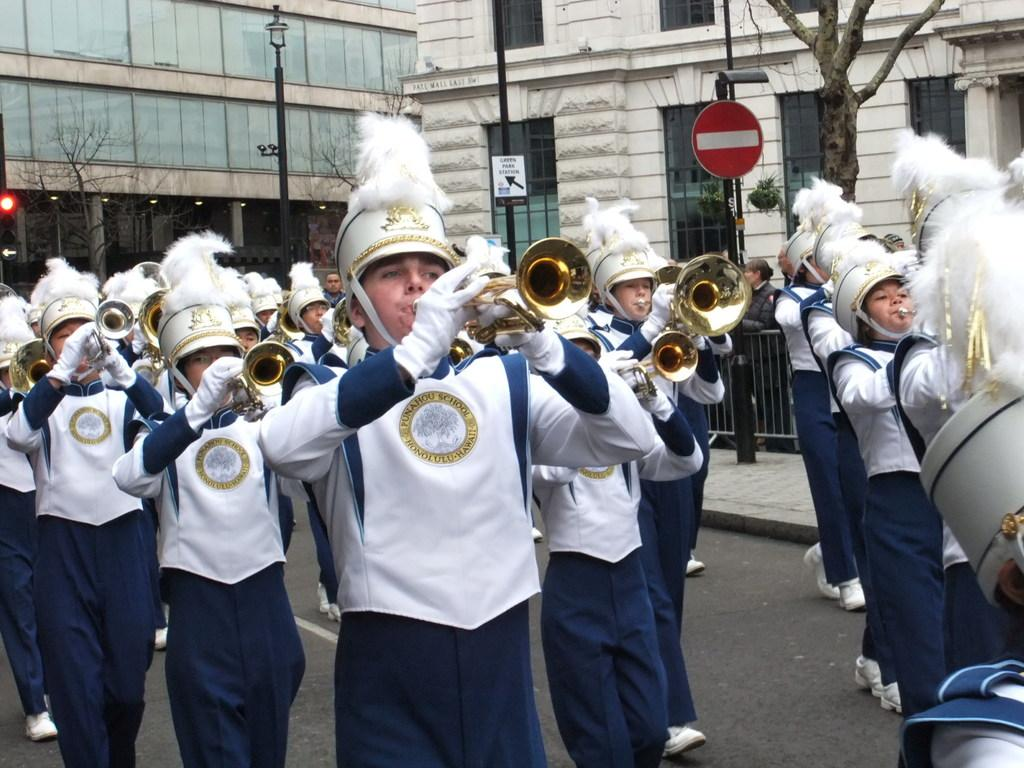What are the people in the image doing? The people in the image are playing musical instruments. What else can be seen in the image besides the people playing instruments? There are buildings, street lamps, and trees visible in the image. Can you see a woman running with a ball in the image? No, there is no woman running with a ball in the image. 